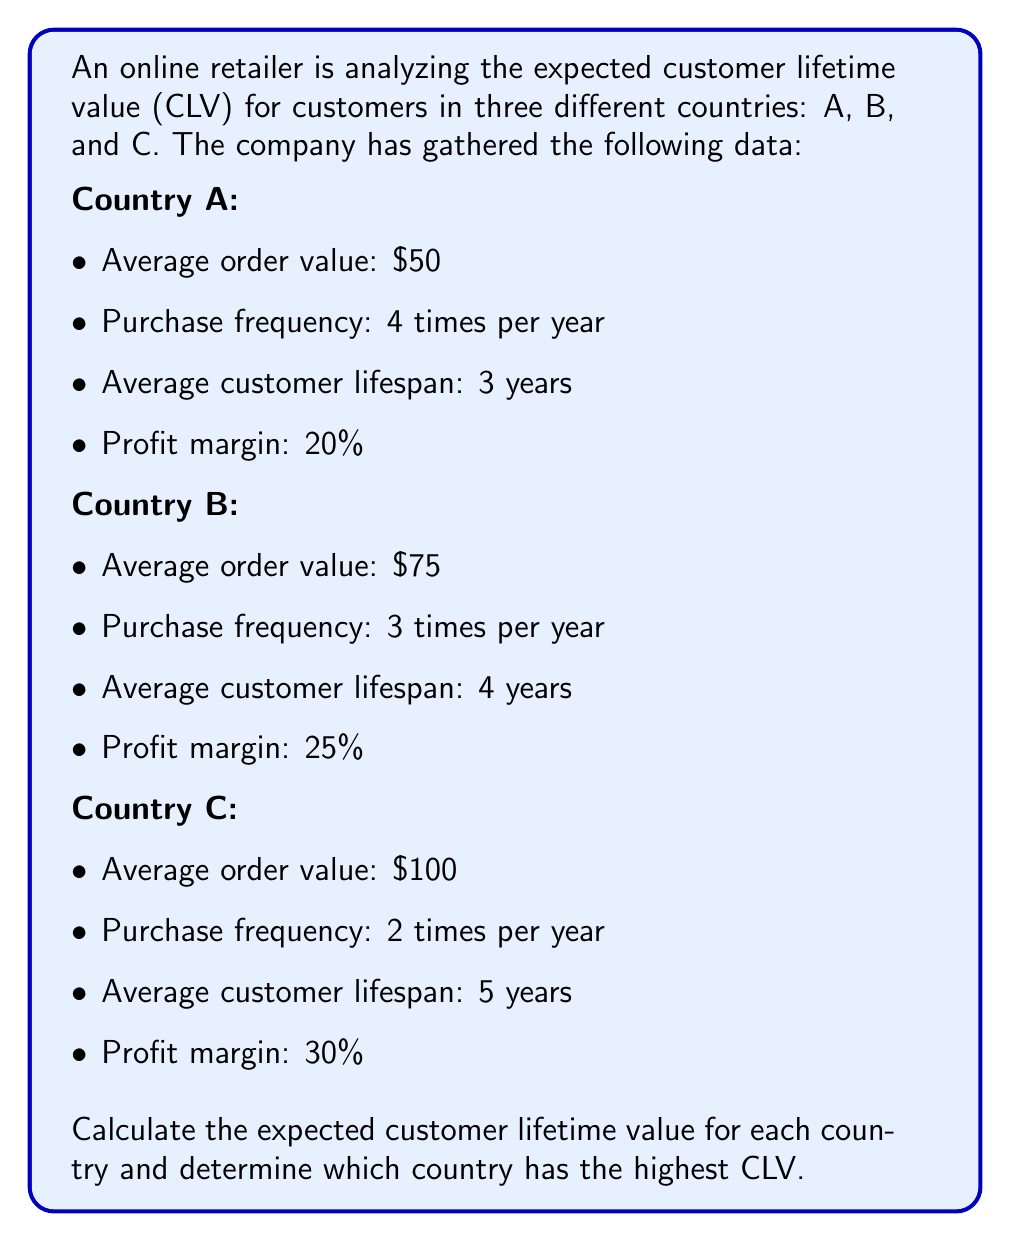Teach me how to tackle this problem. To calculate the Customer Lifetime Value (CLV) for each country, we'll use the following formula:

$$ CLV = AOV \times F \times L \times M $$

Where:
- AOV: Average Order Value
- F: Purchase Frequency (per year)
- L: Average Customer Lifespan (in years)
- M: Profit Margin (as a decimal)

Let's calculate the CLV for each country:

1. Country A:
$$ CLV_A = $50 \times 4 \times 3 \times 0.20 = $120 $$

2. Country B:
$$ CLV_B = $75 \times 3 \times 4 \times 0.25 = $225 $$

3. Country C:
$$ CLV_C = $100 \times 2 \times 5 \times 0.30 = $300 $$

Comparing the results:
- Country A: $120
- Country B: $225
- Country C: $300

Country C has the highest Customer Lifetime Value at $300.
Answer: Country C: $300 